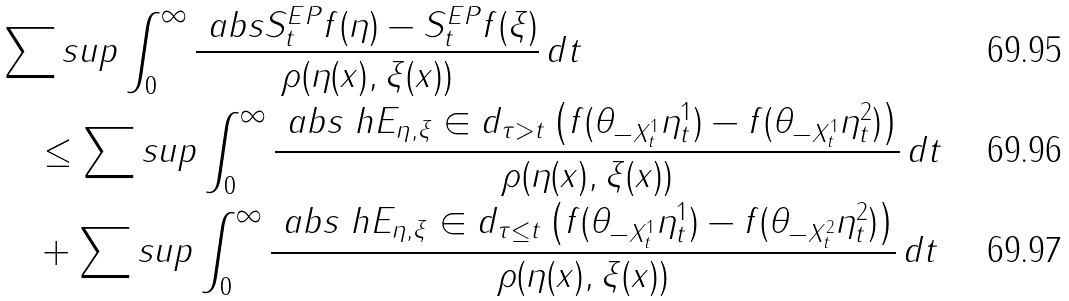<formula> <loc_0><loc_0><loc_500><loc_500>& \sum s u p \int _ { 0 } ^ { \infty } \frac { \ a b s { S _ { t } ^ { E P } f ( \eta ) - S _ { t } ^ { E P } f ( \xi ) } } { \rho ( \eta ( x ) , \xi ( x ) ) } \, d t \\ & \quad \leq \sum s u p \int _ { 0 } ^ { \infty } \frac { \ a b s { \ h E _ { \eta , \xi } \in d _ { \tau > t } \left ( f ( \theta _ { - X _ { t } ^ { 1 } } \eta _ { t } ^ { 1 } ) - f ( \theta _ { - X _ { t } ^ { 1 } } \eta _ { t } ^ { 2 } ) \right ) } } { \rho ( \eta ( x ) , \xi ( x ) ) } \, d t \\ & \quad + \sum s u p \int _ { 0 } ^ { \infty } \frac { \ a b s { \ h E _ { \eta , \xi } \in d _ { \tau \leq t } \left ( f ( \theta _ { - X _ { t } ^ { 1 } } \eta _ { t } ^ { 1 } ) - f ( \theta _ { - X _ { t } ^ { 2 } } \eta _ { t } ^ { 2 } ) \right ) } } { \rho ( \eta ( x ) , \xi ( x ) ) } \, d t</formula> 